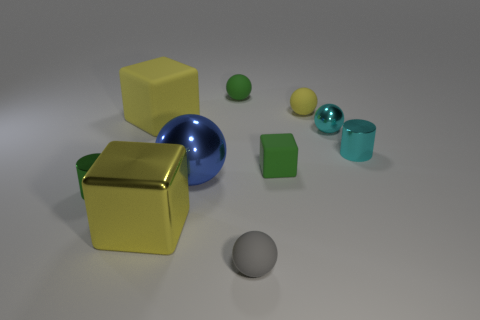Subtract all cyan spheres. How many spheres are left? 4 Subtract all blue balls. How many balls are left? 4 Subtract all red spheres. Subtract all gray blocks. How many spheres are left? 5 Subtract all blocks. How many objects are left? 7 Subtract 0 red balls. How many objects are left? 10 Subtract all big brown rubber cubes. Subtract all green balls. How many objects are left? 9 Add 1 large metallic cubes. How many large metallic cubes are left? 2 Add 4 gray matte balls. How many gray matte balls exist? 5 